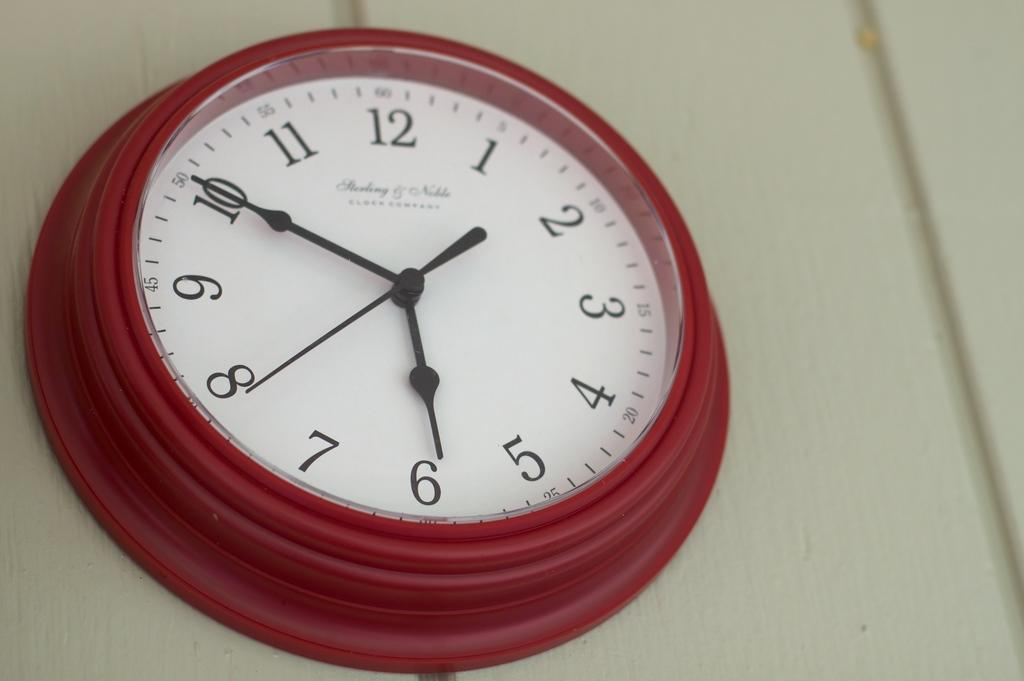What object can be seen in the image that is used for measuring time? There is a clock in the image that is used for measuring time. Where is the clock located in the image? The clock is attached to the wall in the image. What type of tax is being collected by the clock in the image? There is no mention of tax or tax collection in the image; it only features a clock attached to the wall. 